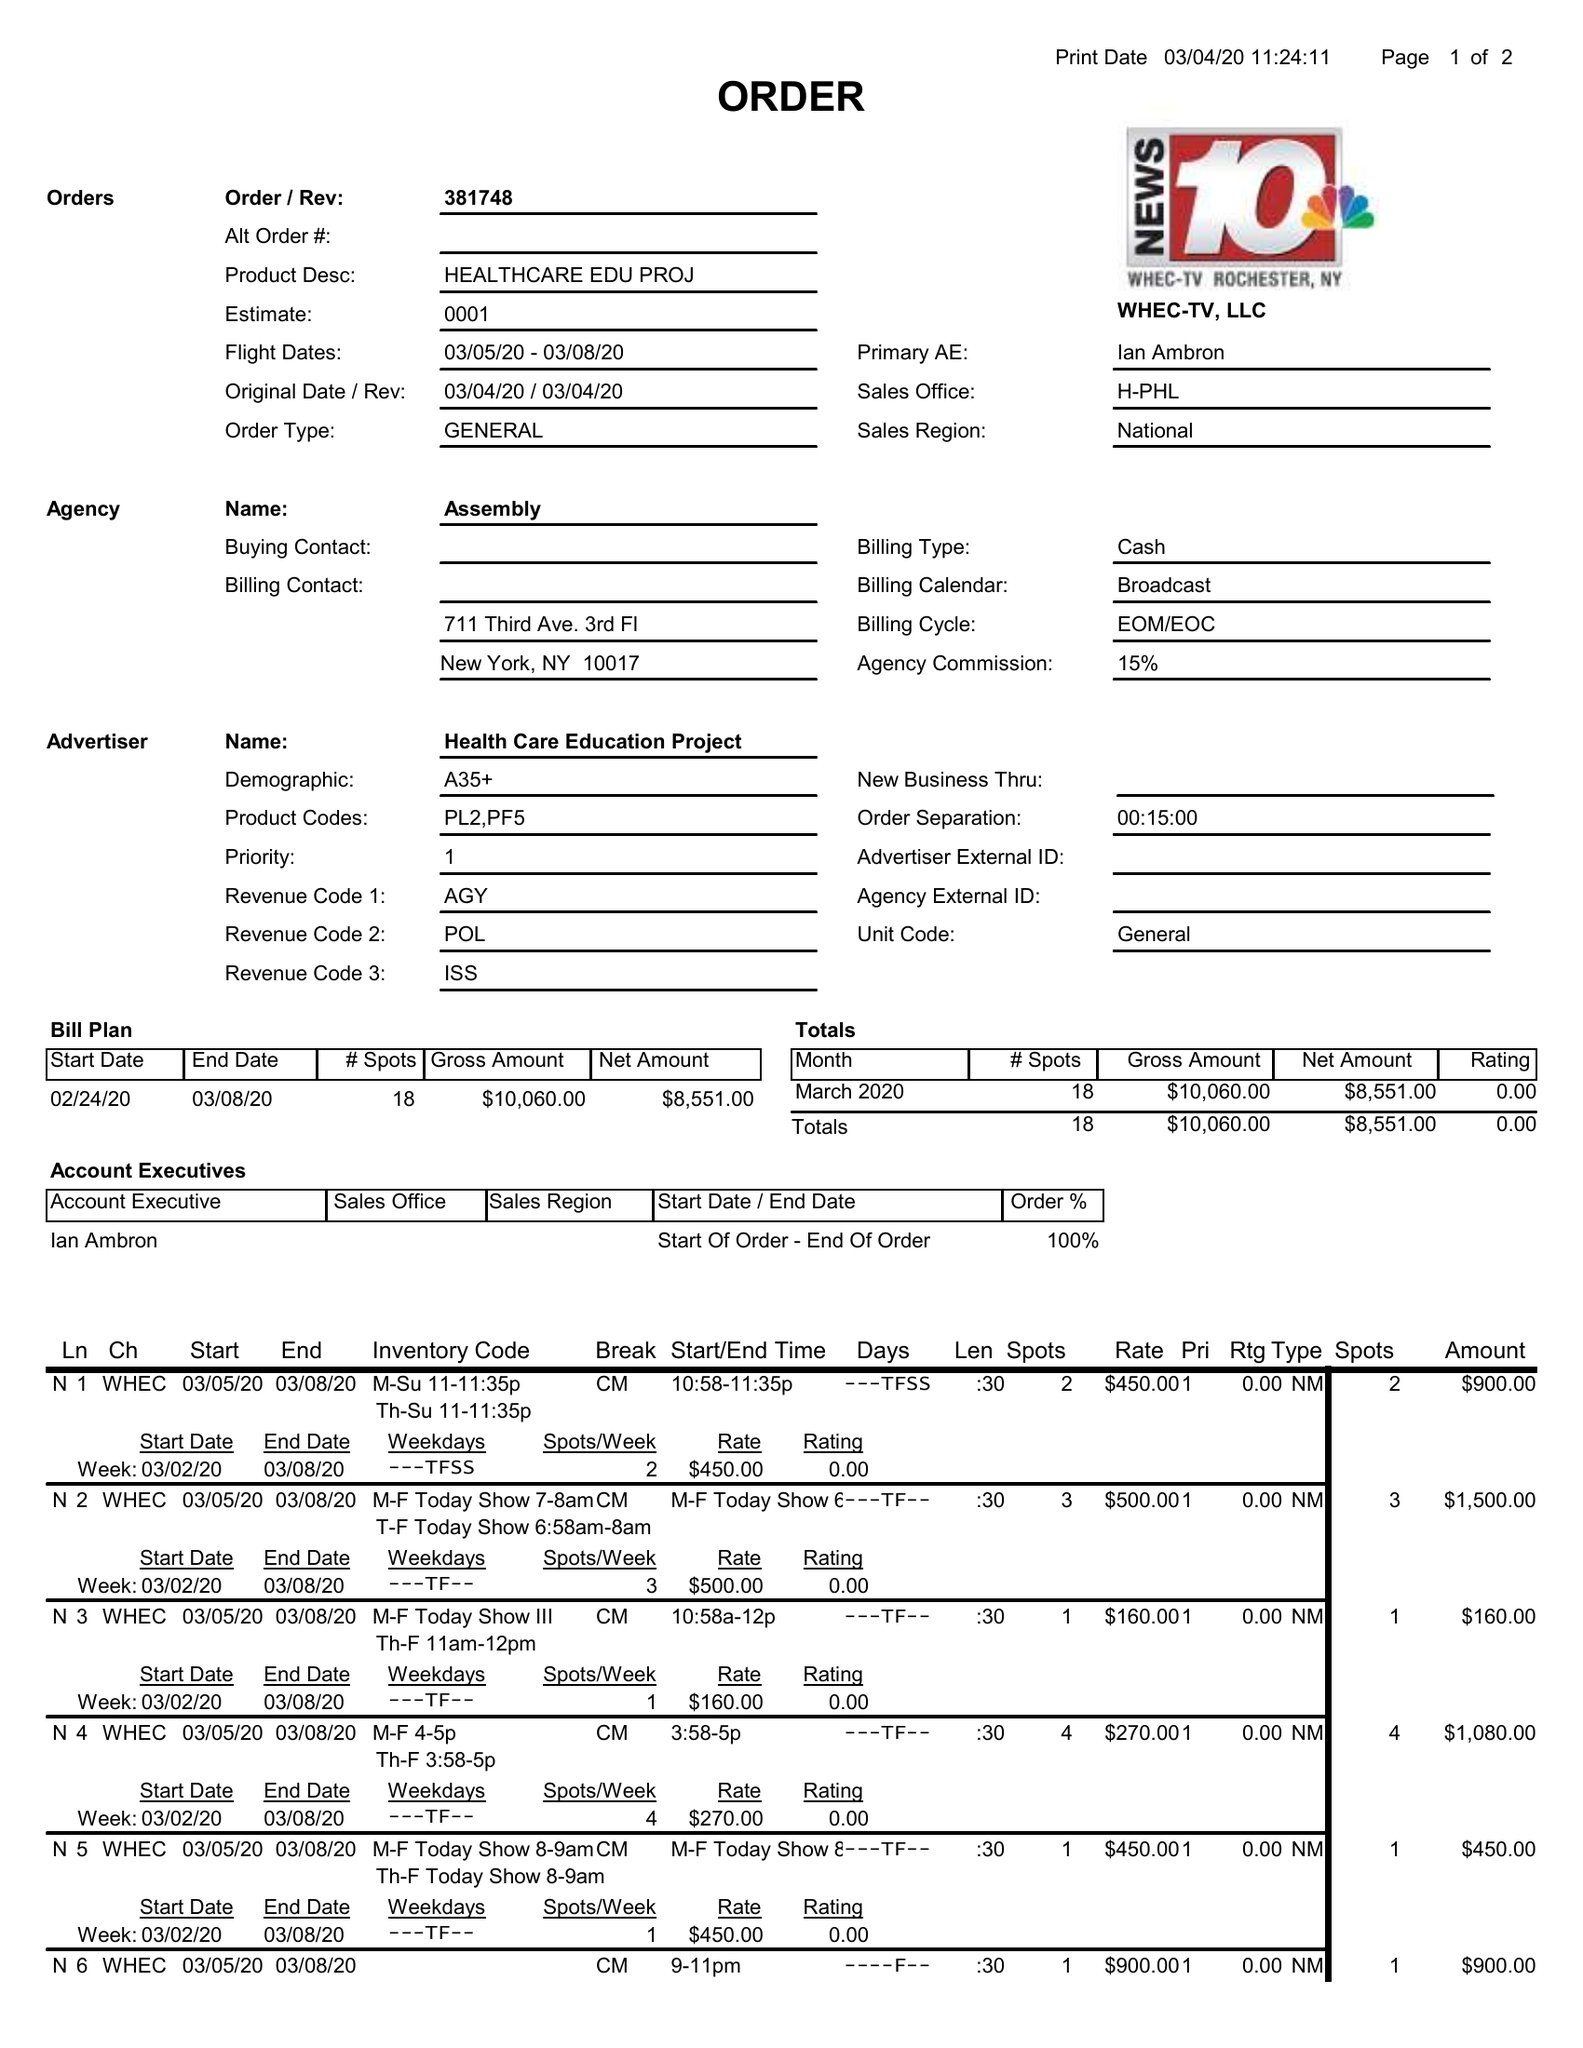What is the value for the flight_to?
Answer the question using a single word or phrase. 03/08/20 